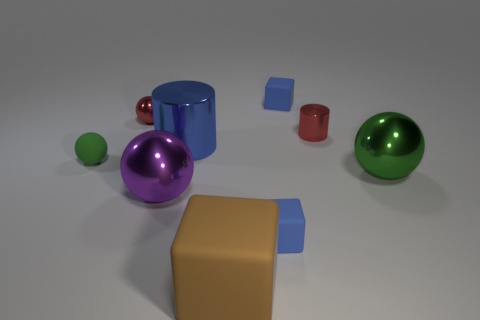Is there a brown metallic cube that has the same size as the green shiny ball?
Give a very brief answer. No. There is a tiny blue block that is in front of the tiny matte sphere; what material is it?
Keep it short and to the point. Rubber. Is the material of the green object that is to the left of the purple sphere the same as the big green thing?
Ensure brevity in your answer.  No. Are any purple balls visible?
Your response must be concise. Yes. What is the color of the large object that is made of the same material as the small green sphere?
Provide a succinct answer. Brown. The small matte cube to the right of the tiny blue block left of the tiny cube behind the tiny rubber ball is what color?
Your response must be concise. Blue. There is a rubber ball; does it have the same size as the shiny object that is on the right side of the red cylinder?
Ensure brevity in your answer.  No. How many objects are either blue matte objects behind the blue shiny cylinder or objects in front of the large purple metallic thing?
Offer a terse response. 3. What shape is the green metal thing that is the same size as the purple sphere?
Give a very brief answer. Sphere. There is a tiny blue matte thing that is in front of the tiny blue cube behind the matte object to the left of the red shiny ball; what is its shape?
Provide a succinct answer. Cube. 